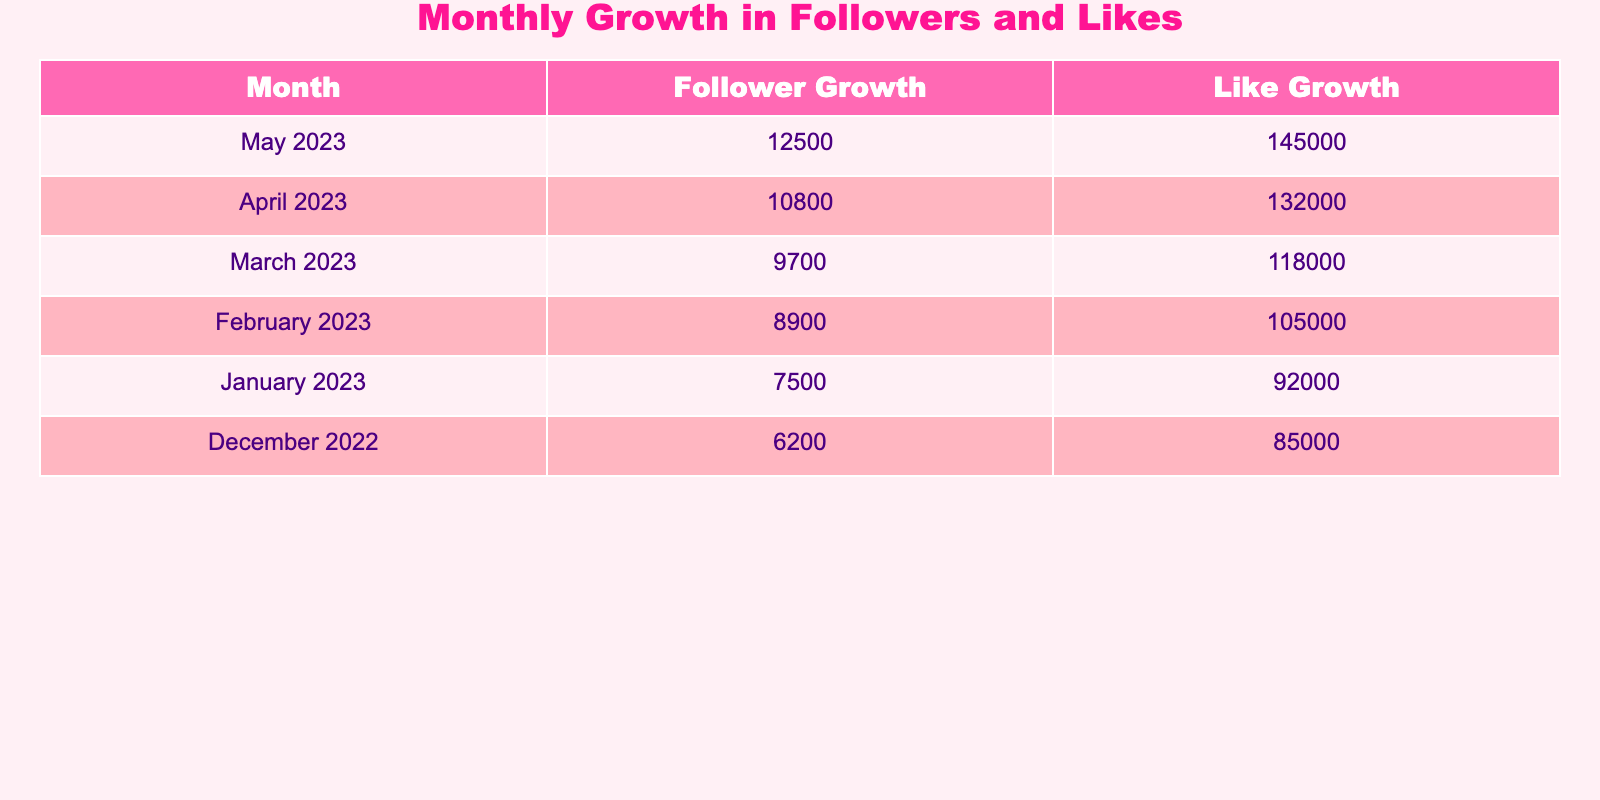What was the highest follower growth recorded in the past 6 months? The table shows follower growth for each month from December 2022 to May 2023. Inspecting the values, the highest follower growth is 12500 in May 2023.
Answer: 12500 What was the lowest like growth recorded in the past 6 months? By looking at the like growth for each month in the table, the lowest value is 85000 in December 2022.
Answer: 85000 What is the total follower growth over the past 6 months? To find the total follower growth, we need to add the follower growth values from December 2022 (6200) through May 2023 (12500). The total is: 6200 + 7500 + 8900 + 9700 + 10800 + 12500 =  59900.
Answer: 59900 What is the average like growth over the past 6 months? To calculate the average like growth, we sum the values from December 2022 (85000) to May 2023 (145000) which gives us: 85000 + 92000 + 105000 + 118000 + 132000 + 145000 =  705000. Then we divide by 6 (the number of months): 705000/6 = 117500.
Answer: 117500 Did follower growth increase every month? By examining the follower growth values month by month in the table, we see the amounts for January (7500), February (8900), March (9700), April (10800), and May (12500), which consistently increase, confirming that follower growth did indeed rise each month.
Answer: Yes Which month had the highest growth in likes? In the table, we compare like growth values: December 2022 (85000), January 2023 (92000), February 2023 (105000), March 2023 (118000), April 2023 (132000), and May 2023 (145000). The highest is in May 2023 with 145000.
Answer: May 2023 How much did the follower growth increase from January 2023 to May 2023? The follower growth values show January 2023 has 7500 and May 2023 has 12500. The difference is calculated by subtracting the two values: 12500 - 7500 = 5000.
Answer: 5000 What trends can be observed in the follower and like growth over the past 6 months? We can analyze the data in the table: both follower growth and like growth show a consistent upward trend each month, indicating a steady increase in popularity and engagement over the last 6 months.
Answer: Both show an upward trend 